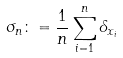<formula> <loc_0><loc_0><loc_500><loc_500>\sigma _ { n } \colon = \frac { 1 } { n } \sum _ { i = 1 } ^ { n } \delta _ { x _ { i } }</formula> 